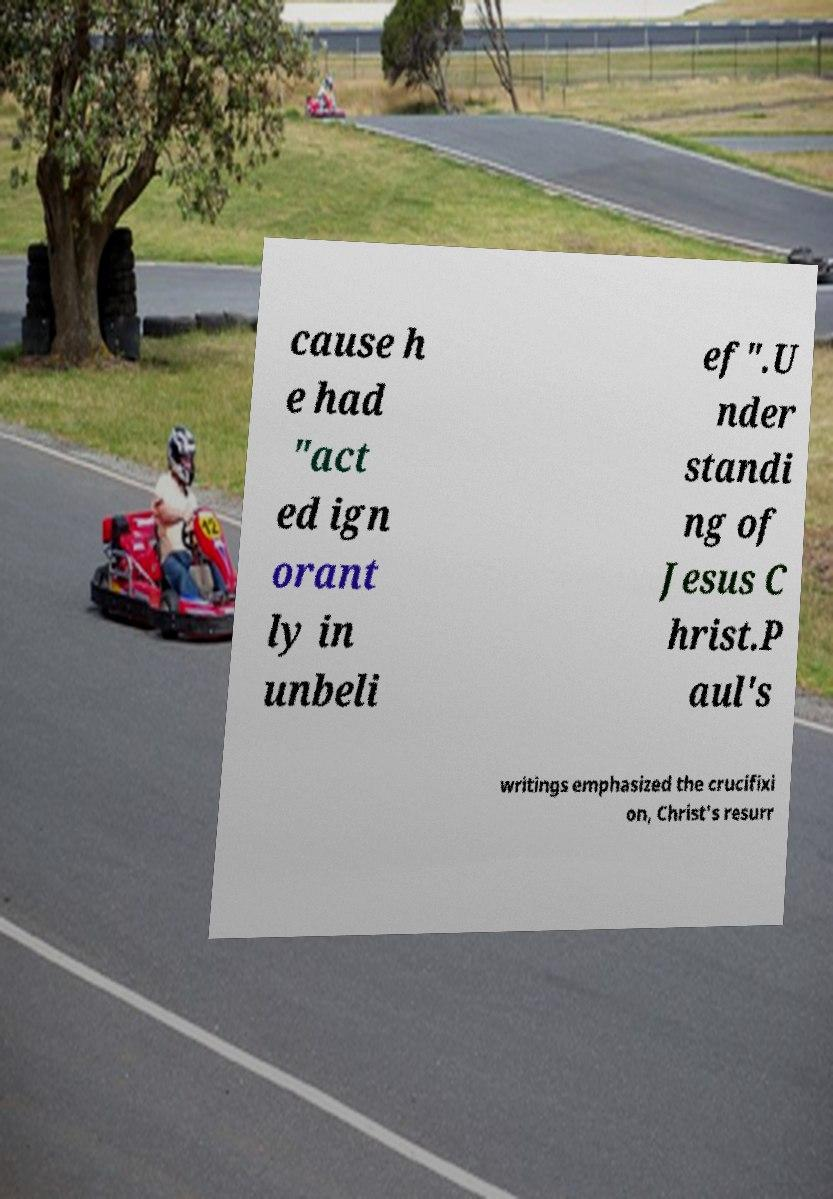What messages or text are displayed in this image? I need them in a readable, typed format. cause h e had "act ed ign orant ly in unbeli ef".U nder standi ng of Jesus C hrist.P aul's writings emphasized the crucifixi on, Christ's resurr 